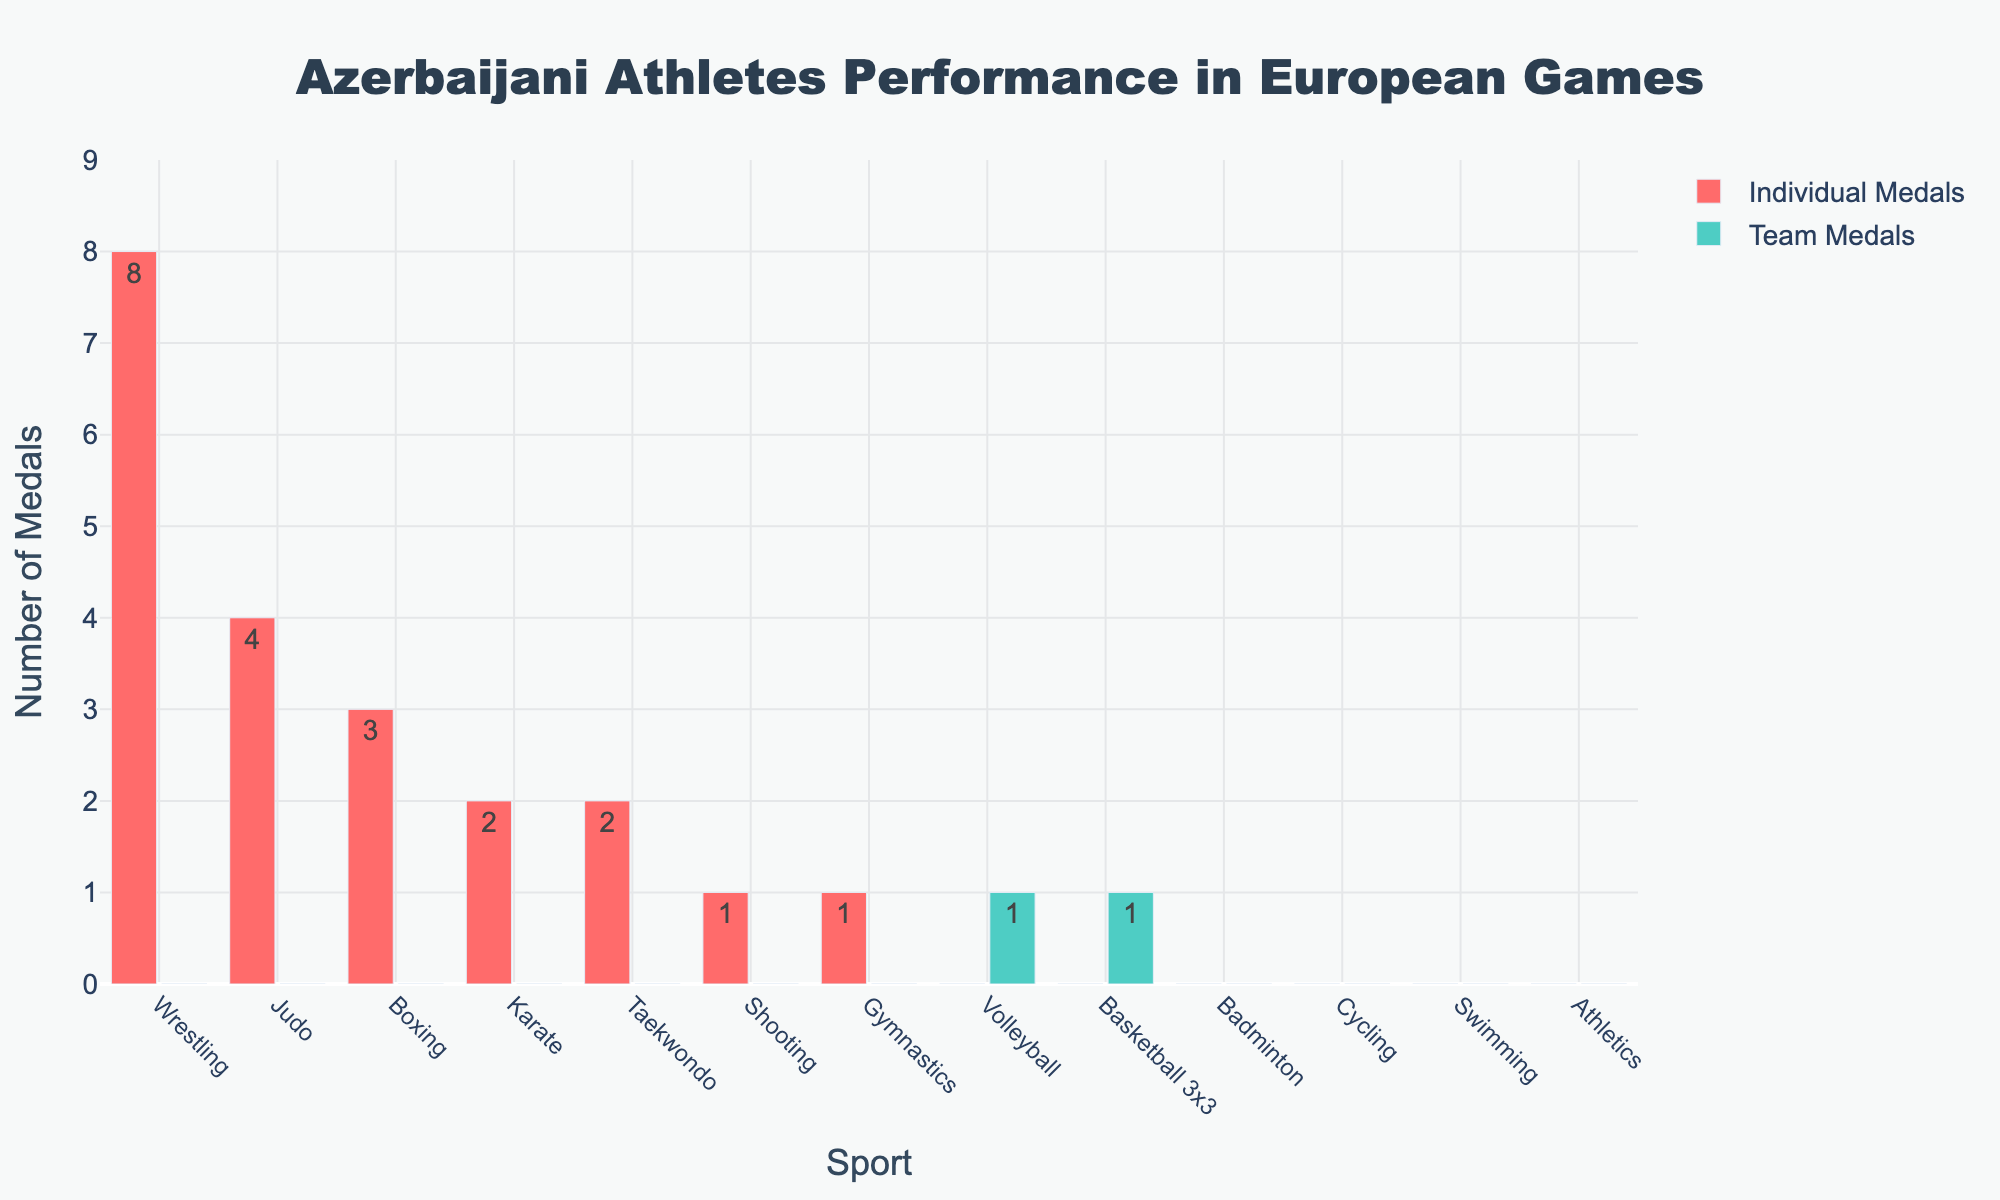What's the total number of individual medals won by Azerbaijani athletes? To find the total number of individual medals, sum the individual medals for each sport: 8 + 4 + 3 + 2 + 2 + 1 + 1 = 21
Answer: 21 Which sport earned the most individual medals? The highest bar for individual medals is associated with Wrestling, with 8 medals
Answer: Wrestling How many sports earned zero medals in both individual and team categories? Look for sports with zero bars in both categories: Badminton, Cycling, Swimming, Athletics. That's 4 sports
Answer: 4 In which sports did Azerbaijani athletes earn only individual medals and not team medals? Look for sports with bars for individual medals and no bars for team medals: Wrestling, Judo, Boxing, Karate, Taekwondo, Shooting, Gymnastics
Answer: Wrestling, Judo, Boxing, Karate, Taekwondo, Shooting, Gymnastics Compare the total team medals to the total individual medals. Which is higher? Sum the team medals (0 + 0 + 0 + 0 + 0 + 1 + 1 = 2) and compare to total individual medals (21). Individual medals are higher
Answer: Individual medals are higher What is the difference in the number of medals between Wrestling (individual) and Gymnastics (individual)? Wrestling has 8 individual medals and Gymnastics has 1, so the difference is 8 - 1 = 7
Answer: 7 Which team sport earned more medals: Volleyball or Basketball 3x3? Compare the bars for team medals; both Volleyball and Basketball 3x3 have 1 medal each
Answer: Neither, they are equal How many medals did Azerbaijani athletes win in combat sports (Wrestling, Judo, Boxing, Karate, Taekwondo) individually? Sum the individual medals for these sports: 8 (Wrestling) + 4 (Judo) + 3 (Boxing) + 2 (Karate) + 2 (Taekwondo) = 19
Answer: 19 What color represents the team medals in the bar chart? The team medals are represented by green-colored bars
Answer: Green Are there any sports where Azerbaijani athletes earned team medals but no individual medals? Check for sports with team medals bars and no individual medals bars: Volleyball and Basketball 3x3
Answer: Volleyball, Basketball 3x3 